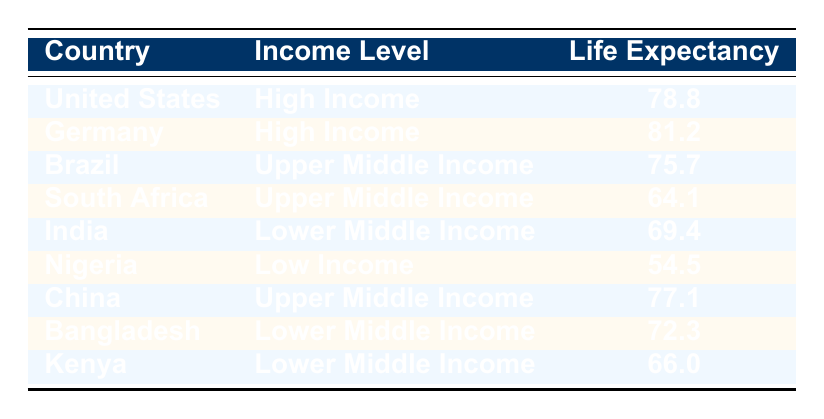What is the life expectancy of Germany? The table shows that Germany's life expectancy is listed directly under the country as 81.2.
Answer: 81.2 Which country has the lowest life expectancy? By looking through the life expectancy values in the table, I see Nigeria with a life expectancy of 54.5, which is the lowest compared to all other countries listed.
Answer: Nigeria What is the average life expectancy of upper middle-income countries? The upper middle-income countries listed are Brazil (75.7), South Africa (64.1), and China (77.1). To calculate the average, we add these values together: 75.7 + 64.1 + 77.1 = 216.9. There are 3 countries, so the average is 216.9 / 3 = 72.3.
Answer: 72.3 Is the life expectancy of India higher than that of Nigeria? India's life expectancy is 69.4, while Nigeria's is 54.5. Since 69.4 is greater than 54.5, the answer is yes.
Answer: Yes Which income level has the highest life expectancy? The highest life expectancy is found among high-income countries. Specifically, Germany has a life expectancy of 81.2, which is higher than any of the others.
Answer: High Income 